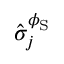<formula> <loc_0><loc_0><loc_500><loc_500>\hat { \sigma } _ { j } ^ { \phi _ { S } }</formula> 